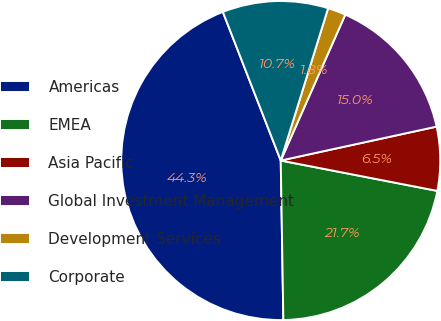Convert chart. <chart><loc_0><loc_0><loc_500><loc_500><pie_chart><fcel>Americas<fcel>EMEA<fcel>Asia Pacific<fcel>Global Investment Management<fcel>Development Services<fcel>Corporate<nl><fcel>44.35%<fcel>21.69%<fcel>6.46%<fcel>14.96%<fcel>1.83%<fcel>10.71%<nl></chart> 